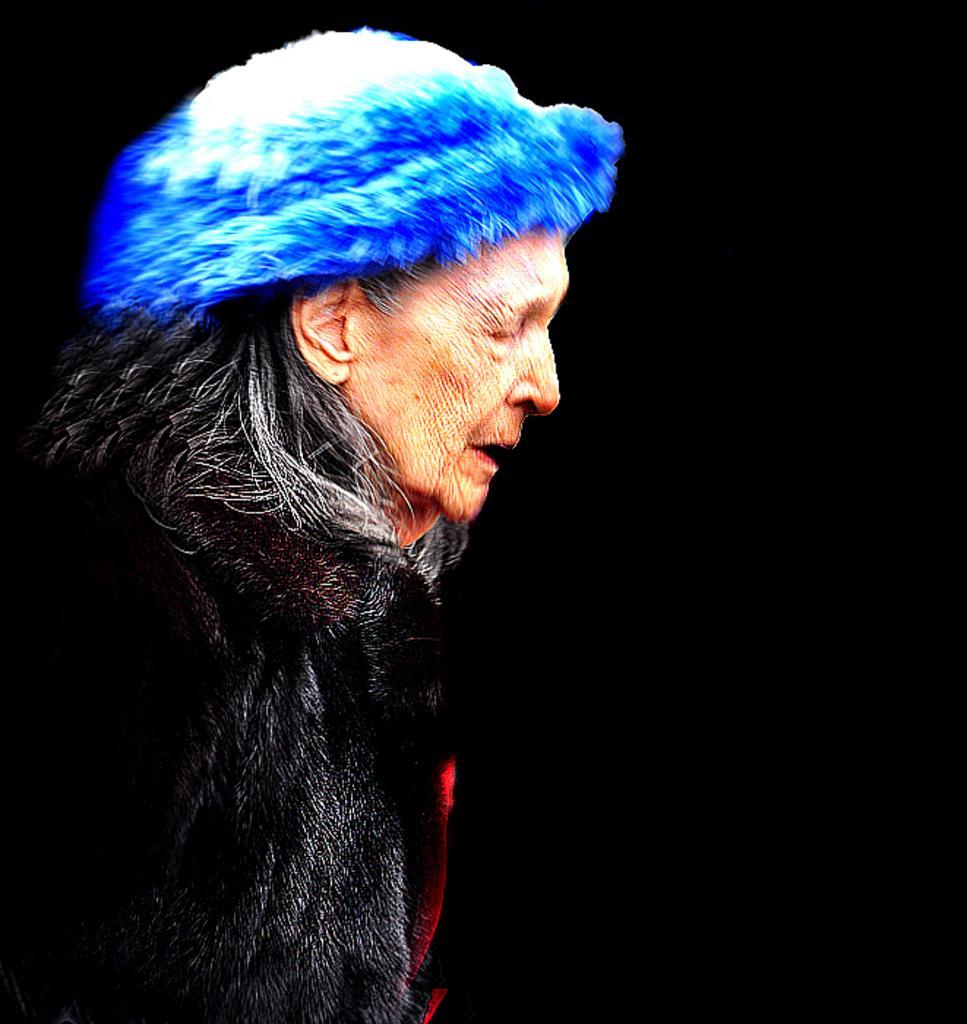Can you describe this image briefly? In this image, I can see an old woman standing. The background looks dark. 